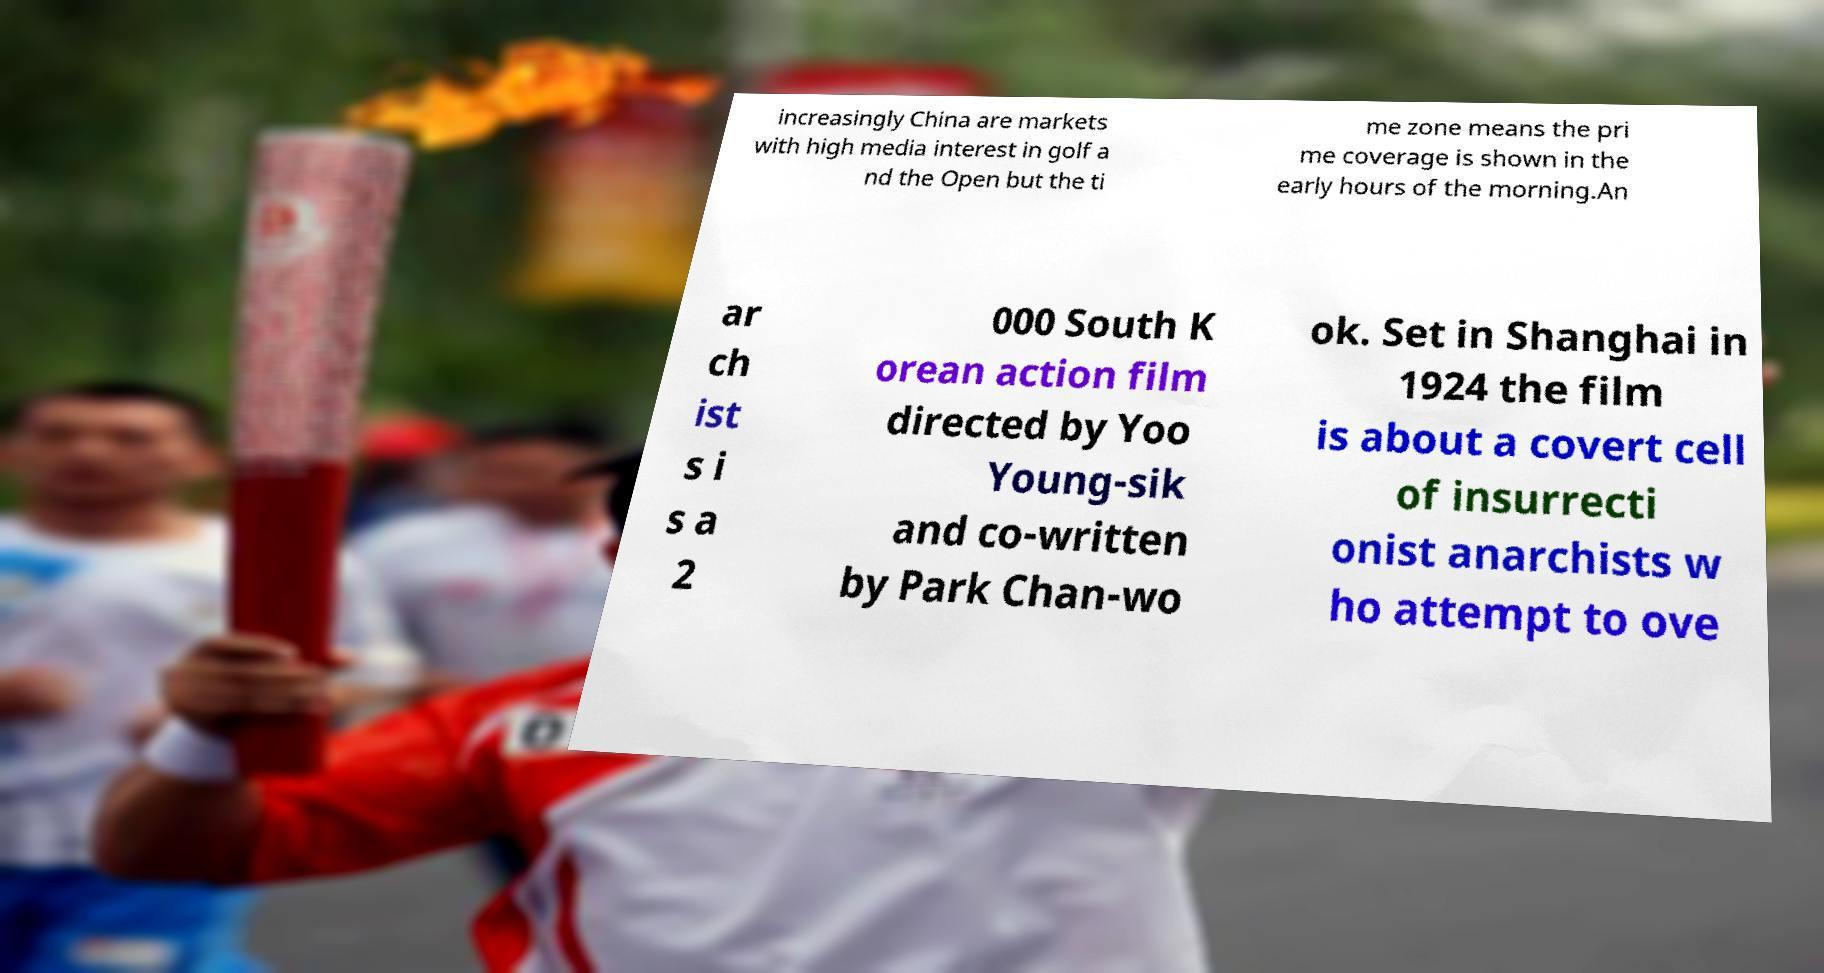What messages or text are displayed in this image? I need them in a readable, typed format. increasingly China are markets with high media interest in golf a nd the Open but the ti me zone means the pri me coverage is shown in the early hours of the morning.An ar ch ist s i s a 2 000 South K orean action film directed by Yoo Young-sik and co-written by Park Chan-wo ok. Set in Shanghai in 1924 the film is about a covert cell of insurrecti onist anarchists w ho attempt to ove 